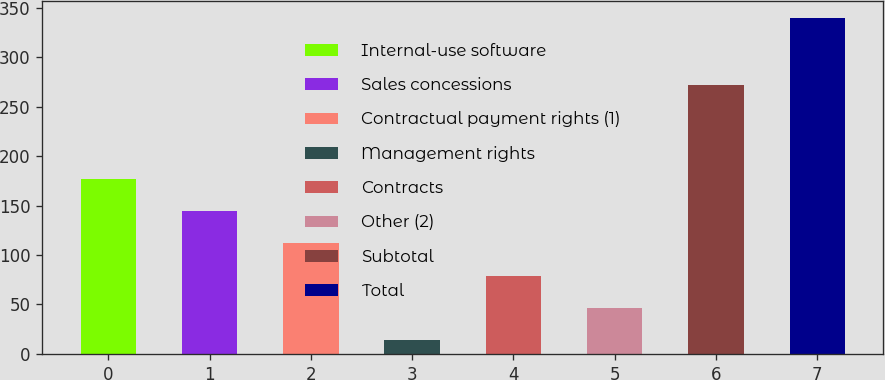Convert chart to OTSL. <chart><loc_0><loc_0><loc_500><loc_500><bar_chart><fcel>Internal-use software<fcel>Sales concessions<fcel>Contractual payment rights (1)<fcel>Management rights<fcel>Contracts<fcel>Other (2)<fcel>Subtotal<fcel>Total<nl><fcel>177<fcel>144.4<fcel>111.8<fcel>14<fcel>79.2<fcel>46.6<fcel>272<fcel>340<nl></chart> 